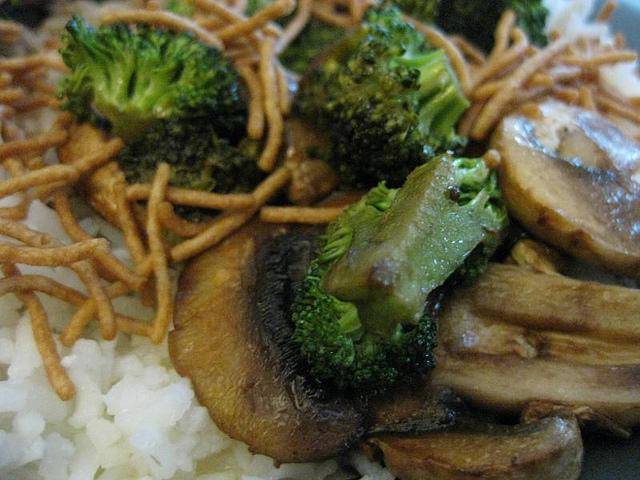What is the vegetable in this dish other than the broccoli? mushroom 